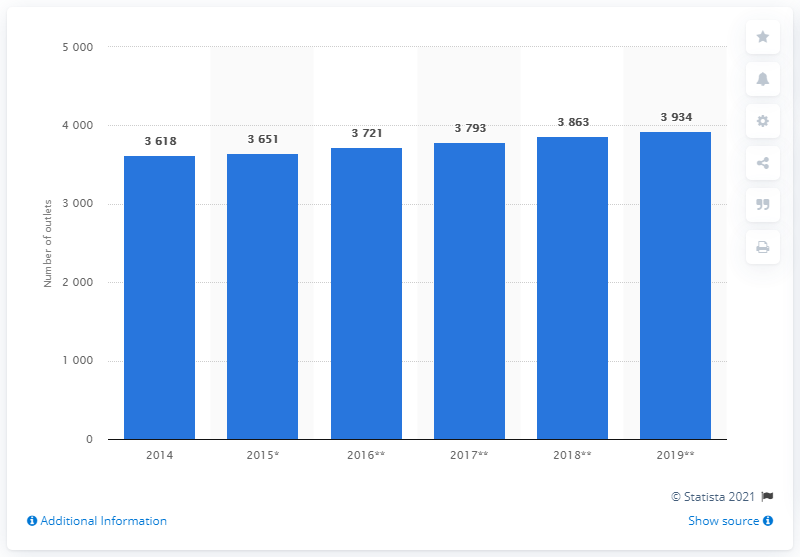List a handful of essential elements in this visual. In 2014, Tesco's total of 3,618 outlets in the UK was forecasted to increase to 3,934 by 2019. 